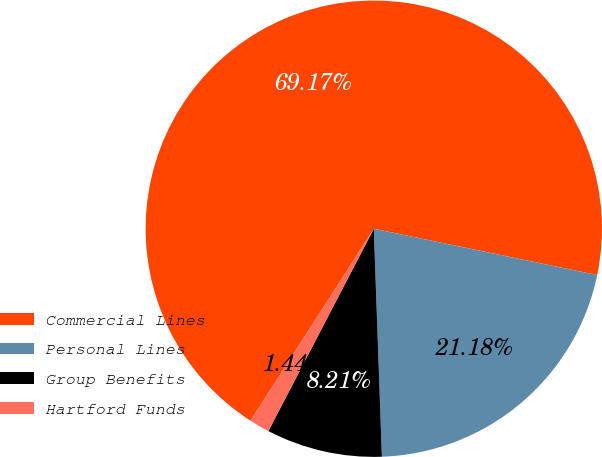Convert chart to OTSL. <chart><loc_0><loc_0><loc_500><loc_500><pie_chart><fcel>Commercial Lines<fcel>Personal Lines<fcel>Group Benefits<fcel>Hartford Funds<nl><fcel>69.17%<fcel>21.18%<fcel>8.21%<fcel>1.44%<nl></chart> 